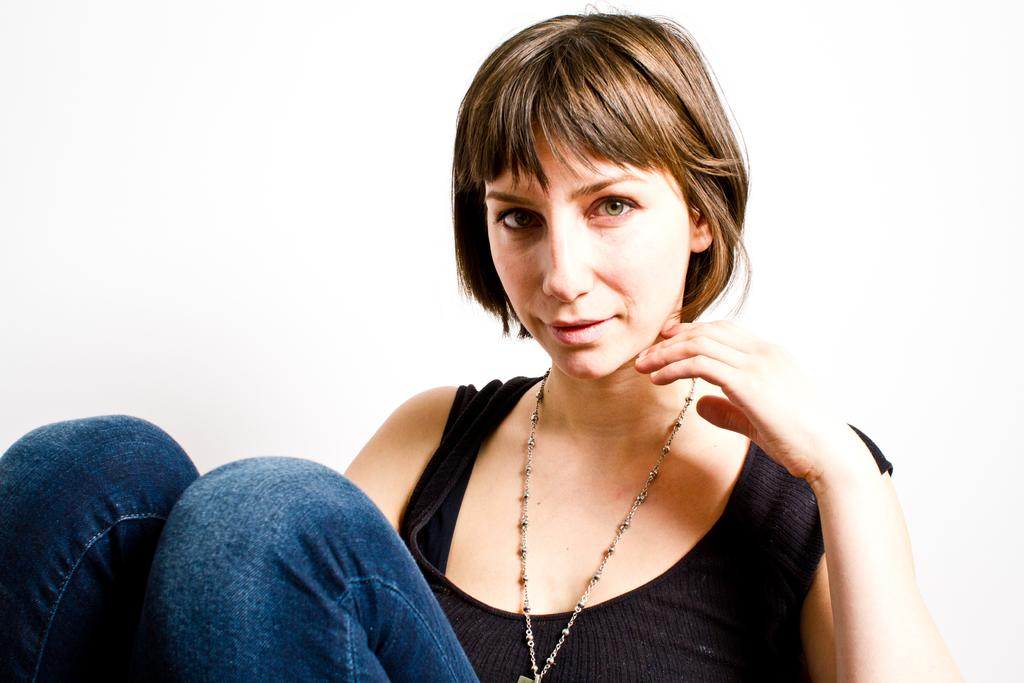What is the main subject of the image? The main subject of the image is a woman. Can you describe the woman's clothing in the image? The woman is wearing a black vest and jeans in the image. Are there any accessories visible on the woman? Yes, the woman is wearing a necklace in the image. What is the woman doing in the image? The woman is sitting in the image. What is the woman's facial expression in the image? The woman is smiling in the image. What type of jam does the woman have on her sandwich in the image? There is no sandwich or jam present in the image; it only features a woman sitting and smiling. 